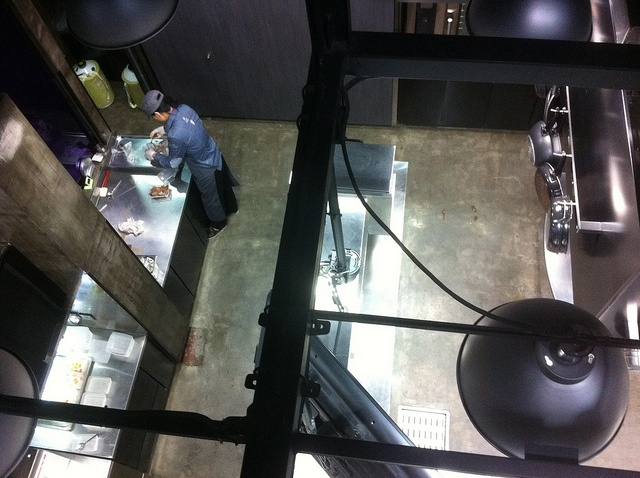Describe the objects in this image and their specific colors. I can see tv in black, gray, blue, and darkblue tones, people in black, gray, and darkblue tones, and spoon in black, lightgray, darkgray, and gray tones in this image. 